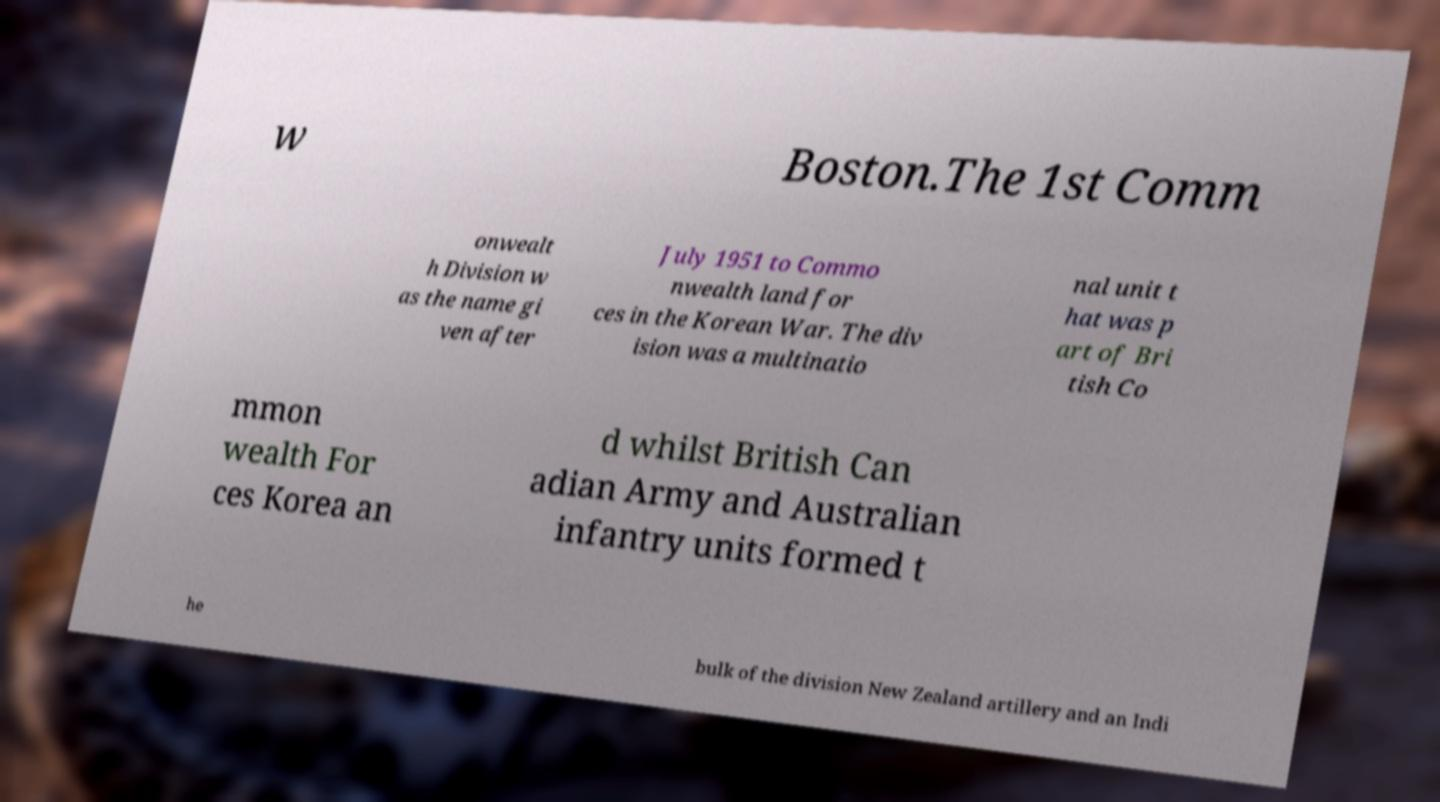For documentation purposes, I need the text within this image transcribed. Could you provide that? w Boston.The 1st Comm onwealt h Division w as the name gi ven after July 1951 to Commo nwealth land for ces in the Korean War. The div ision was a multinatio nal unit t hat was p art of Bri tish Co mmon wealth For ces Korea an d whilst British Can adian Army and Australian infantry units formed t he bulk of the division New Zealand artillery and an Indi 